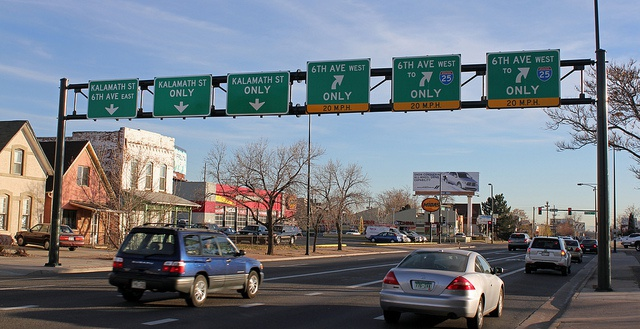Describe the objects in this image and their specific colors. I can see car in darkgray, black, and gray tones, car in darkgray, black, gray, and lightgray tones, car in darkgray, black, and gray tones, car in darkgray, black, maroon, and gray tones, and car in darkgray, black, gray, and maroon tones in this image. 